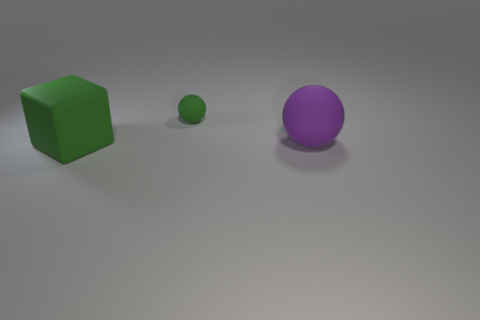Is there any other thing that is the same size as the green matte ball?
Offer a very short reply. No. There is a thing that is on the right side of the green rubber thing that is to the right of the green matte thing in front of the purple thing; what is its shape?
Offer a terse response. Sphere. Are the green block and the purple ball made of the same material?
Keep it short and to the point. Yes. Do the rubber thing that is in front of the big purple sphere and the large matte sphere have the same color?
Ensure brevity in your answer.  No. Is the number of green objects right of the green sphere greater than the number of tiny green rubber objects behind the large green object?
Your answer should be compact. No. Is there anything else that is the same color as the large block?
Offer a very short reply. Yes. How many things are either big rubber spheres or blue shiny things?
Your response must be concise. 1. Do the rubber thing on the right side of the green matte ball and the green matte cube have the same size?
Your answer should be compact. Yes. What number of other things are there of the same size as the purple rubber object?
Give a very brief answer. 1. Is there a small cyan block?
Make the answer very short. No. 